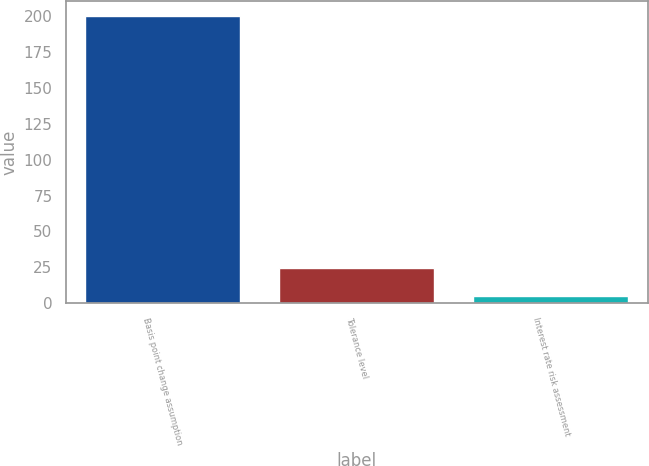Convert chart. <chart><loc_0><loc_0><loc_500><loc_500><bar_chart><fcel>Basis point change assumption<fcel>Tolerance level<fcel>Interest rate risk assessment<nl><fcel>200<fcel>24.4<fcel>4.89<nl></chart> 